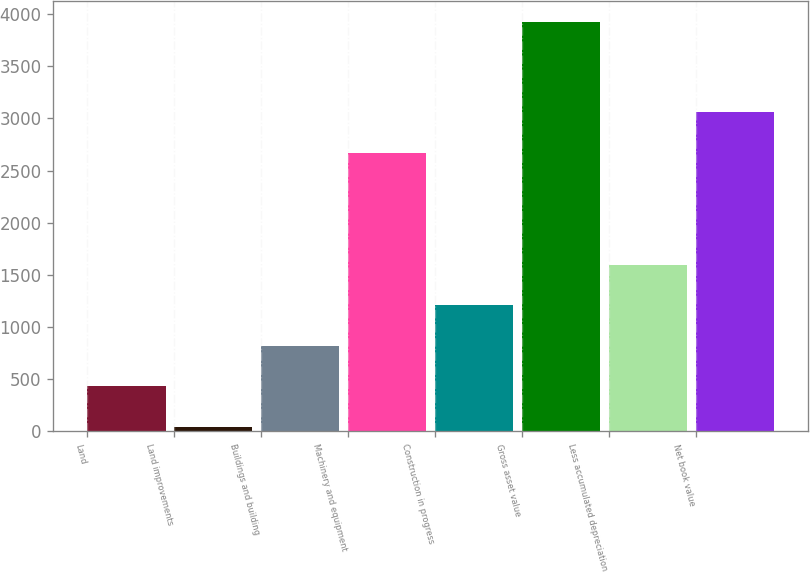Convert chart. <chart><loc_0><loc_0><loc_500><loc_500><bar_chart><fcel>Land<fcel>Land improvements<fcel>Buildings and building<fcel>Machinery and equipment<fcel>Construction in progress<fcel>Gross asset value<fcel>Less accumulated depreciation<fcel>Net book value<nl><fcel>432.3<fcel>44<fcel>820.6<fcel>2669<fcel>1208.9<fcel>3927<fcel>1597.2<fcel>3057.3<nl></chart> 